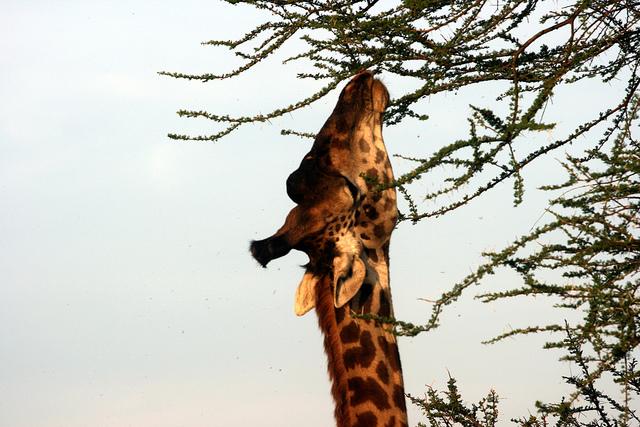What is the giraffe trying to do?
Short answer required. Eat. What is the weather like?
Concise answer only. Sunny. What is beside the animal?
Answer briefly. Tree. 